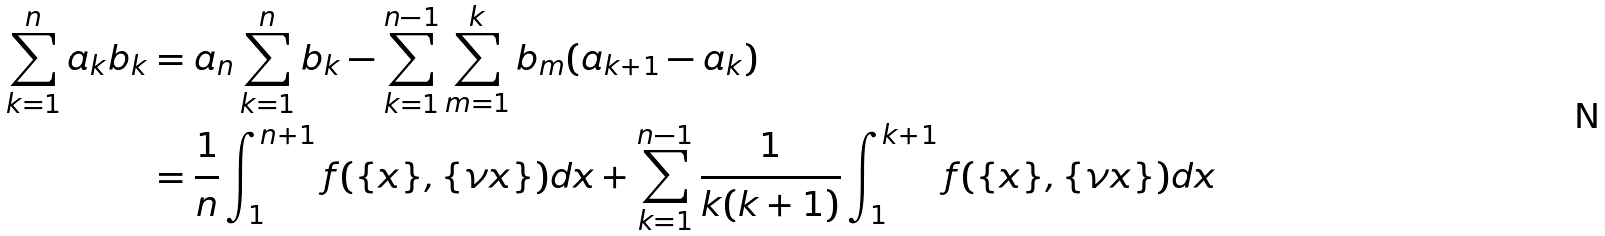<formula> <loc_0><loc_0><loc_500><loc_500>\sum _ { k = 1 } ^ { n } a _ { k } b _ { k } & = a _ { n } \sum _ { k = 1 } ^ { n } b _ { k } - \sum _ { k = 1 } ^ { n - 1 } \sum _ { m = 1 } ^ { k } b _ { m } ( a _ { k + 1 } - a _ { k } ) \\ & = \frac { 1 } { n } \int _ { 1 } ^ { n + 1 } f ( \{ x \} , \{ \nu x \} ) d x + \sum _ { k = 1 } ^ { n - 1 } \frac { 1 } { k ( k + 1 ) } \int _ { 1 } ^ { k + 1 } f ( \{ x \} , \{ \nu x \} ) d x</formula> 